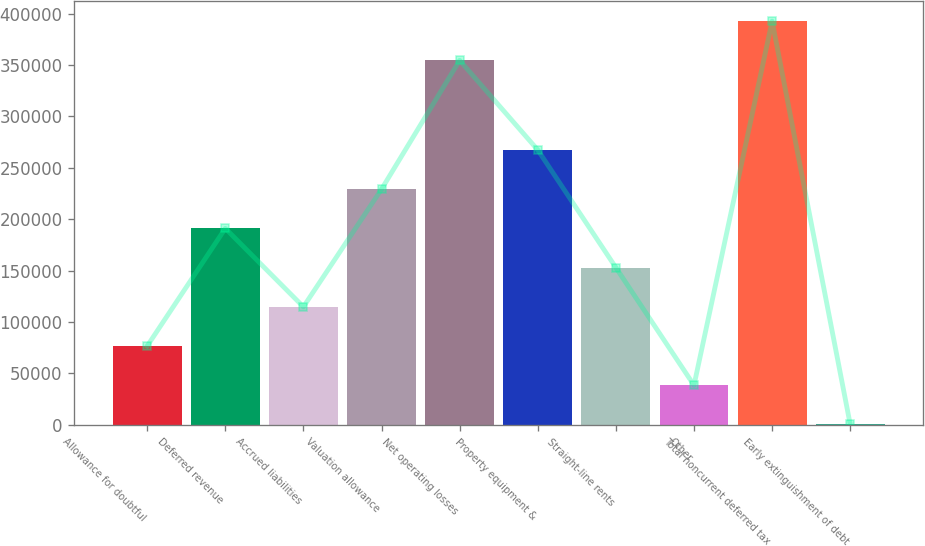Convert chart. <chart><loc_0><loc_0><loc_500><loc_500><bar_chart><fcel>Allowance for doubtful<fcel>Deferred revenue<fcel>Accrued liabilities<fcel>Valuation allowance<fcel>Net operating losses<fcel>Property equipment &<fcel>Straight-line rents<fcel>Other<fcel>Total noncurrent deferred tax<fcel>Early extinguishment of debt<nl><fcel>76581.8<fcel>191028<fcel>114731<fcel>229177<fcel>354459<fcel>267326<fcel>152880<fcel>38432.9<fcel>392608<fcel>284<nl></chart> 